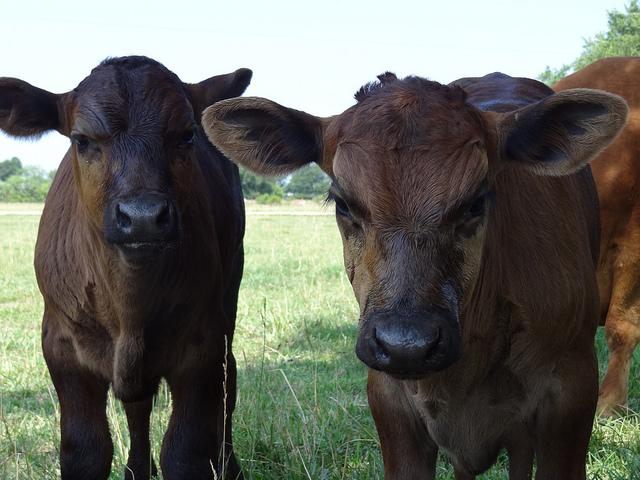Are the cows standing or sitting?
Short answer required. Standing. How many cows can be seen?
Give a very brief answer. 3. Does the cow on the right look angry?
Be succinct. Yes. 